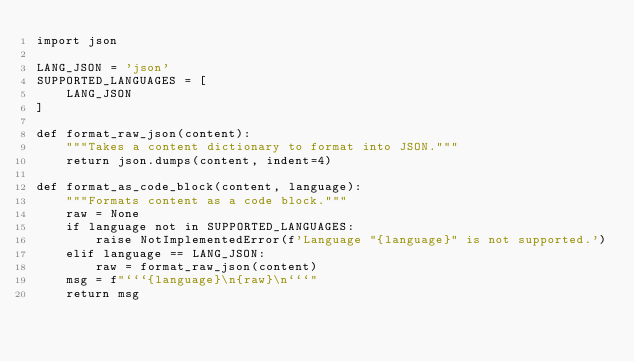Convert code to text. <code><loc_0><loc_0><loc_500><loc_500><_Python_>import json

LANG_JSON = 'json'
SUPPORTED_LANGUAGES = [
    LANG_JSON
]

def format_raw_json(content):
    """Takes a content dictionary to format into JSON."""
    return json.dumps(content, indent=4)

def format_as_code_block(content, language):
    """Formats content as a code block."""
    raw = None
    if language not in SUPPORTED_LANGUAGES:
        raise NotImplementedError(f'Language "{language}" is not supported.')
    elif language == LANG_JSON:
        raw = format_raw_json(content)
    msg = f"```{language}\n{raw}\n```" 
    return msg</code> 